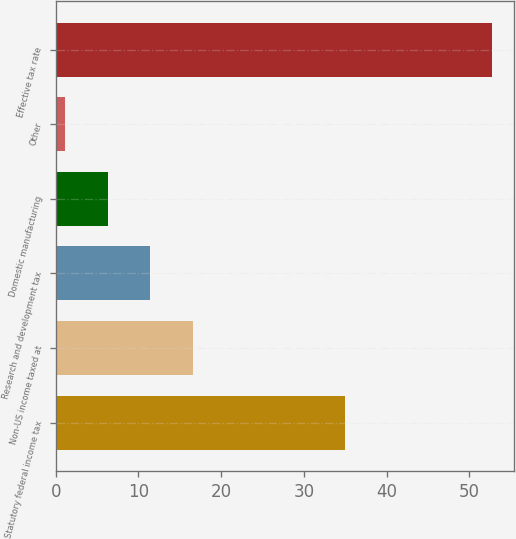Convert chart. <chart><loc_0><loc_0><loc_500><loc_500><bar_chart><fcel>Statutory federal income tax<fcel>Non-US income taxed at<fcel>Research and development tax<fcel>Domestic manufacturing<fcel>Other<fcel>Effective tax rate<nl><fcel>35<fcel>16.61<fcel>11.44<fcel>6.27<fcel>1.1<fcel>52.8<nl></chart> 